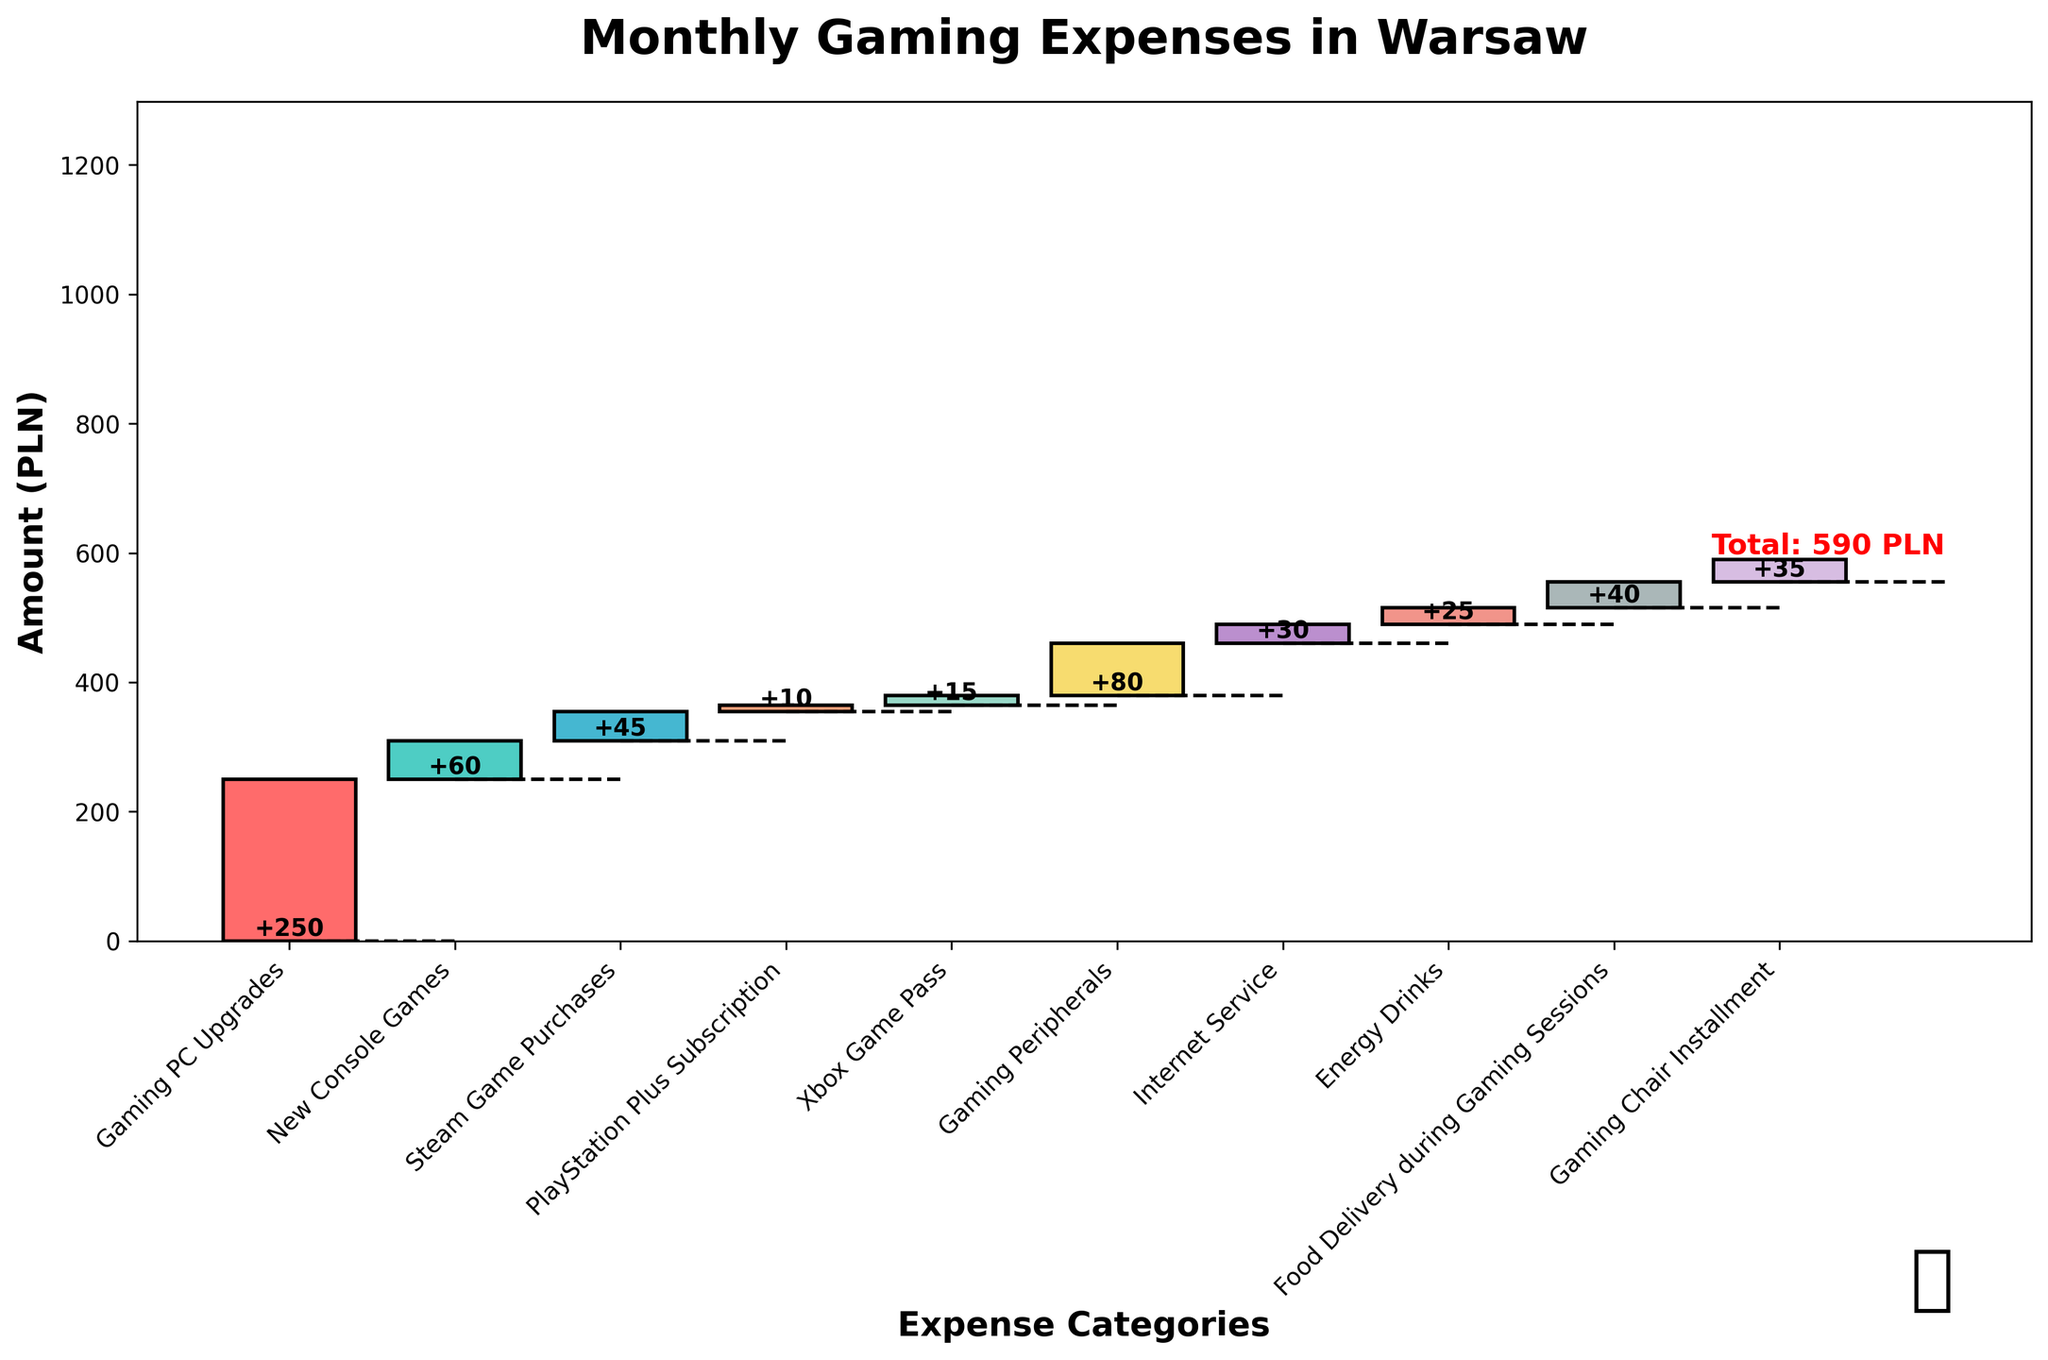What is the title of the plot? The title is located at the top of the chart and is usually in a larger and bold font to stand out.
Answer: Monthly Gaming Expenses in Warsaw What is the value of the Gaming Peripherals expense? Locate the bar labeled "Gaming Peripherals" and look at the value displayed above it or at the height in the y-axis.
Answer: 80 PLN How much is spent on subscriptions (PlayStation Plus and Xbox Game Pass)? Identify the bars labeled "PlayStation Plus Subscription" and "Xbox Game Pass", then sum their values (10 + 15).
Answer: 25 PLN Which expense category has the highest value? Compare the heights (or values above) of each bar to determine which one is the tallest.
Answer: Gaming PC Upgrades What is the sum of the expenses for Gaming Peripherals, Internet Service, and Energy Drinks? Locate the values for "Gaming Peripherals", "Internet Service", and "Energy Drinks" and calculate their sum (80 + 30 + 25).
Answer: 135 PLN In which category is 40 PLN spent? Locate the bar with the label that corresponds to the value of 40 PLN.
Answer: Food Delivery during Gaming Sessions What is the total of monthly expenses? The total is indicated at the end of the waterfall chart; it can also be verified by summing all individual expenses.
Answer: 590 PLN Which expense categories lie between the PlayStation Plus Subscription and Energy Drinks in terms of value? Compare the values of "PlayStation Plus Subscription" and "Energy Drinks" (10 and 25, respectively) and check which categories have values between these two.
Answer: Steam Game Purchases, Xbox Game Pass, Internet Service Is the expenditure on a Gaming Chair Installment greater than on Steam Game Purchases? Compare the values of "Gaming Chair Installment" and "Steam Game Purchases" (35 vs. 45).
Answer: No How much more is spent on Gaming PC Upgrades compared to New Console Games? Subtract the value of "New Console Games" from "Gaming PC Upgrades" (250 - 60).
Answer: 190 PLN 